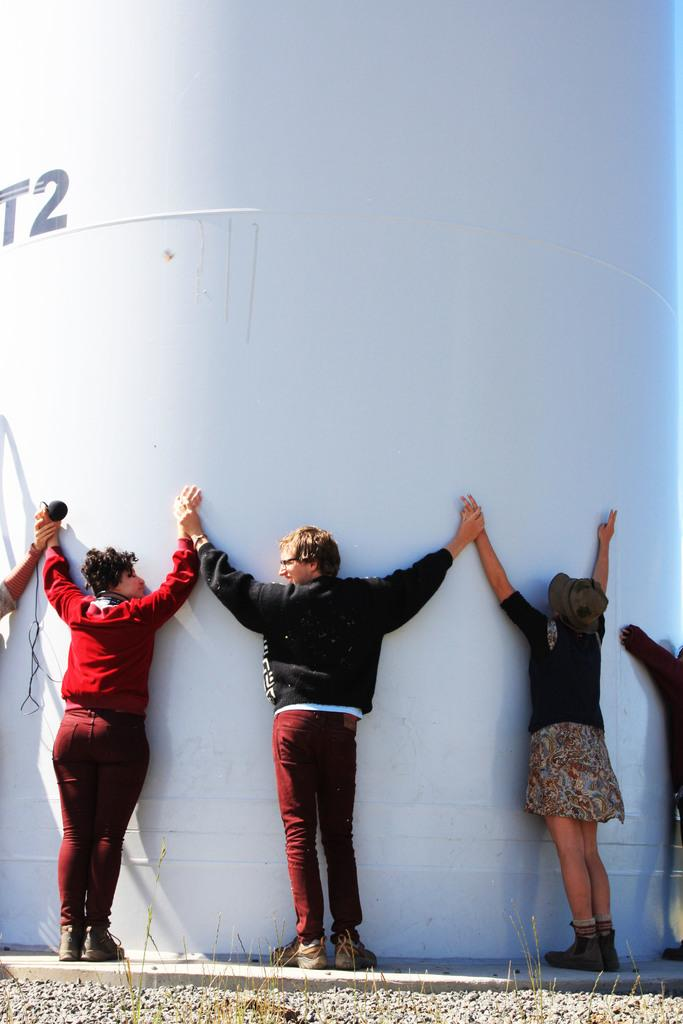Who or what can be seen in the image? There are people in the image. What are the people wearing? The people are wearing clothes. Where are the people standing in the image? The people are standing in front of a wall. What type of prose can be heard being read by the people in the image? There is no indication in the image that the people are reading or listening to any prose, so it cannot be determined from the picture. 